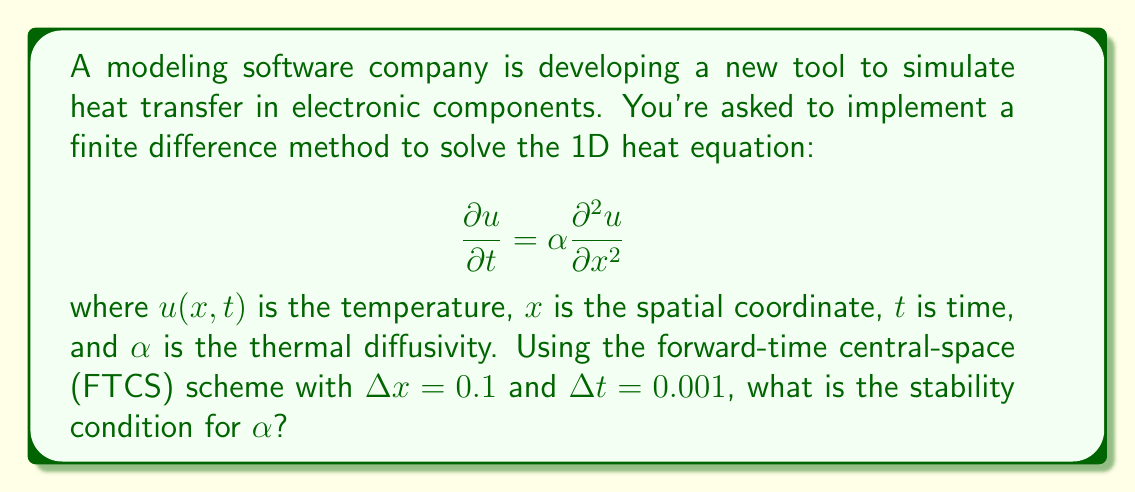Provide a solution to this math problem. To solve this problem, we need to apply the FTCS scheme to the 1D heat equation and determine the stability condition.

1) The FTCS scheme for the 1D heat equation is:

   $$\frac{u_i^{n+1} - u_i^n}{\Delta t} = \alpha \frac{u_{i+1}^n - 2u_i^n + u_{i-1}^n}{(\Delta x)^2}$$

2) Rearranging this equation:

   $$u_i^{n+1} = u_i^n + \alpha \frac{\Delta t}{(\Delta x)^2} (u_{i+1}^n - 2u_i^n + u_{i-1}^n)$$

3) For stability, the coefficient of $u_i^n$ must be non-negative:

   $$1 - 2\alpha \frac{\Delta t}{(\Delta x)^2} \geq 0$$

4) This leads to the stability condition:

   $$\alpha \frac{\Delta t}{(\Delta x)^2} \leq \frac{1}{2}$$

5) Substituting the given values $\Delta x = 0.1$ and $\Delta t = 0.001$:

   $$\alpha \frac{0.001}{(0.1)^2} \leq \frac{1}{2}$$

6) Simplifying:

   $$\alpha \cdot 0.1 \leq \frac{1}{2}$$

7) Solving for $\alpha$:

   $$\alpha \leq 5$$

Therefore, the stability condition for $\alpha$ is $\alpha \leq 5$.
Answer: $\alpha \leq 5$ 